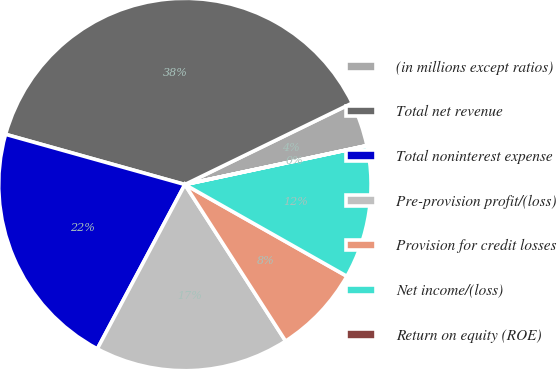Convert chart to OTSL. <chart><loc_0><loc_0><loc_500><loc_500><pie_chart><fcel>(in millions except ratios)<fcel>Total net revenue<fcel>Total noninterest expense<fcel>Pre-provision profit/(loss)<fcel>Provision for credit losses<fcel>Net income/(loss)<fcel>Return on equity (ROE)<nl><fcel>3.86%<fcel>38.44%<fcel>21.55%<fcel>16.89%<fcel>7.7%<fcel>11.54%<fcel>0.01%<nl></chart> 